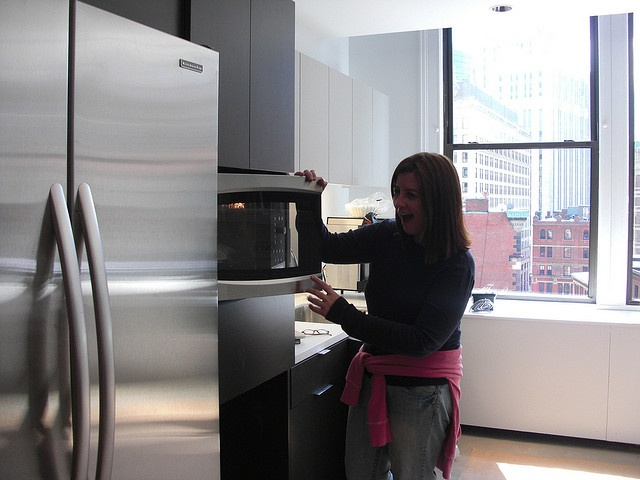Describe the objects in this image and their specific colors. I can see refrigerator in gray, darkgray, black, and lightgray tones, people in gray, black, maroon, and brown tones, and microwave in gray, black, darkgray, and maroon tones in this image. 